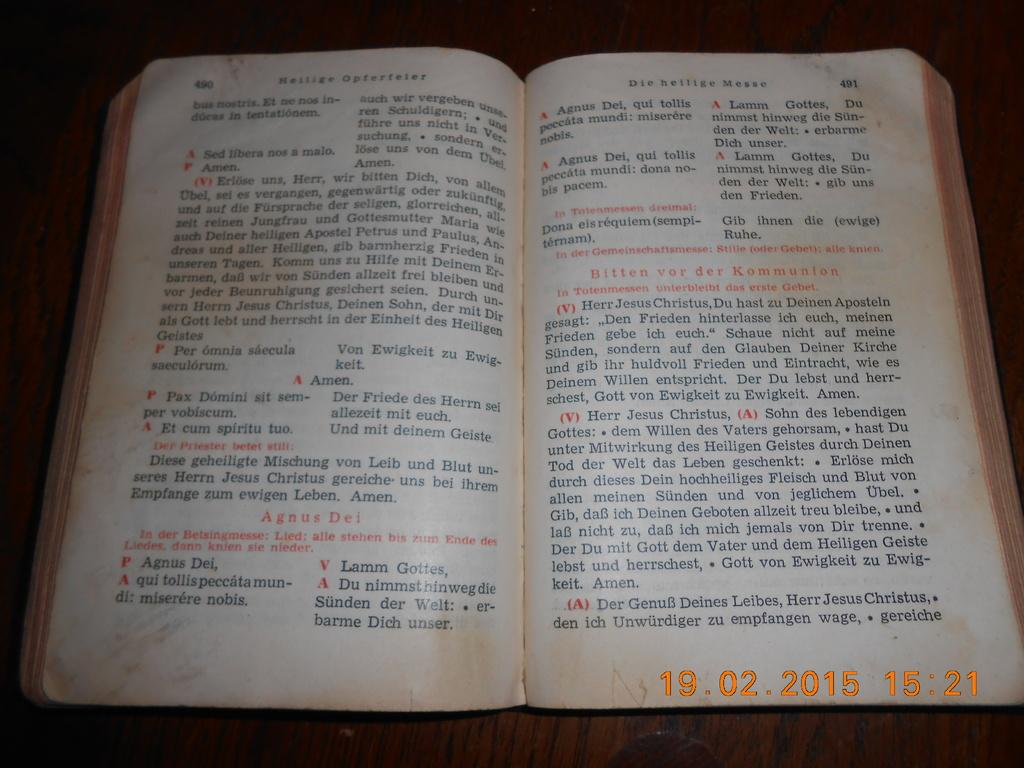<image>
Offer a succinct explanation of the picture presented. An open bible in a language other than English with a date stamp of 19.02.2015 